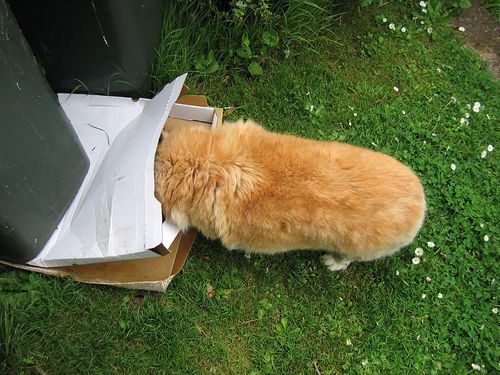<image>
Is there a dog in the box? Yes. The dog is contained within or inside the box, showing a containment relationship. Is the dog in the package? Yes. The dog is contained within or inside the package, showing a containment relationship. Is the cat in front of the box? No. The cat is not in front of the box. The spatial positioning shows a different relationship between these objects. 